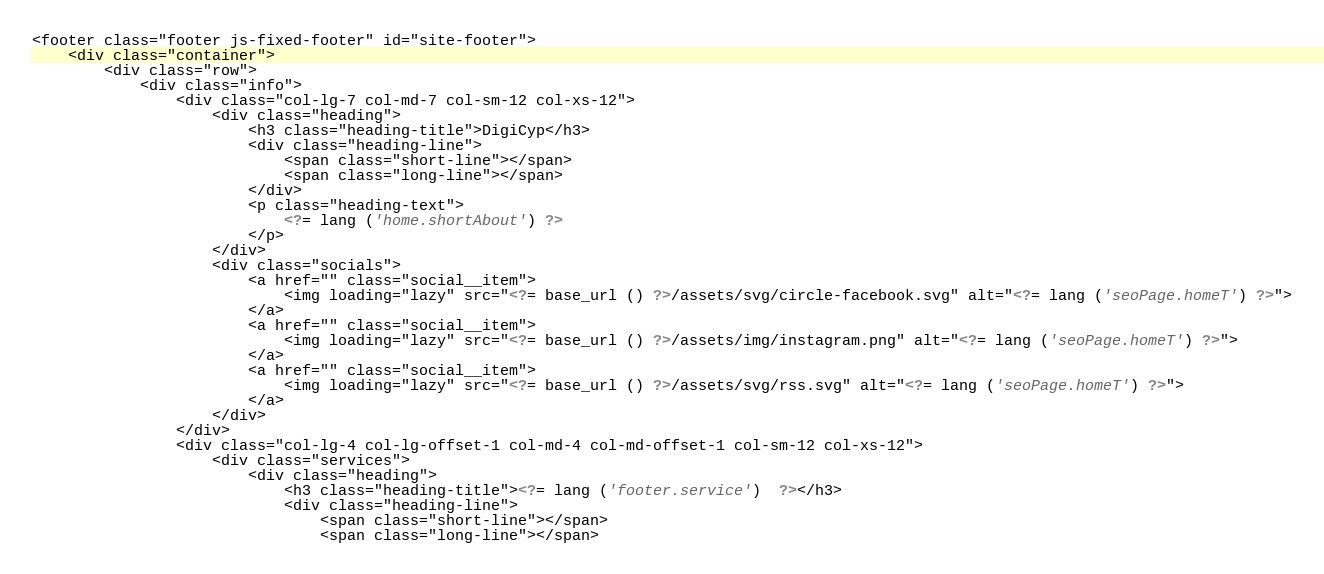<code> <loc_0><loc_0><loc_500><loc_500><_PHP_><footer class="footer js-fixed-footer" id="site-footer">
	<div class="container">
		<div class="row">
			<div class="info">
				<div class="col-lg-7 col-md-7 col-sm-12 col-xs-12">
					<div class="heading">
						<h3 class="heading-title">DigiCyp</h3>
						<div class="heading-line">
							<span class="short-line"></span>
							<span class="long-line"></span>
						</div>
						<p class="heading-text">
                            <?= lang ('home.shortAbout') ?>
						</p>
					</div>
					<div class="socials">
						<a href="" class="social__item">
							<img loading="lazy" src="<?= base_url () ?>/assets/svg/circle-facebook.svg" alt="<?= lang ('seoPage.homeT') ?>">
						</a>
						<a href="" class="social__item">
							<img loading="lazy" src="<?= base_url () ?>/assets/img/instagram.png" alt="<?= lang ('seoPage.homeT') ?>">
						</a>
						<a href="" class="social__item">
							<img loading="lazy" src="<?= base_url () ?>/assets/svg/rss.svg" alt="<?= lang ('seoPage.homeT') ?>">
						</a>
					</div>
				</div>
				<div class="col-lg-4 col-lg-offset-1 col-md-4 col-md-offset-1 col-sm-12 col-xs-12">
					<div class="services">
						<div class="heading">
							<h3 class="heading-title"><?= lang ('footer.service')  ?></h3>
							<div class="heading-line">
								<span class="short-line"></span>
								<span class="long-line"></span></code> 